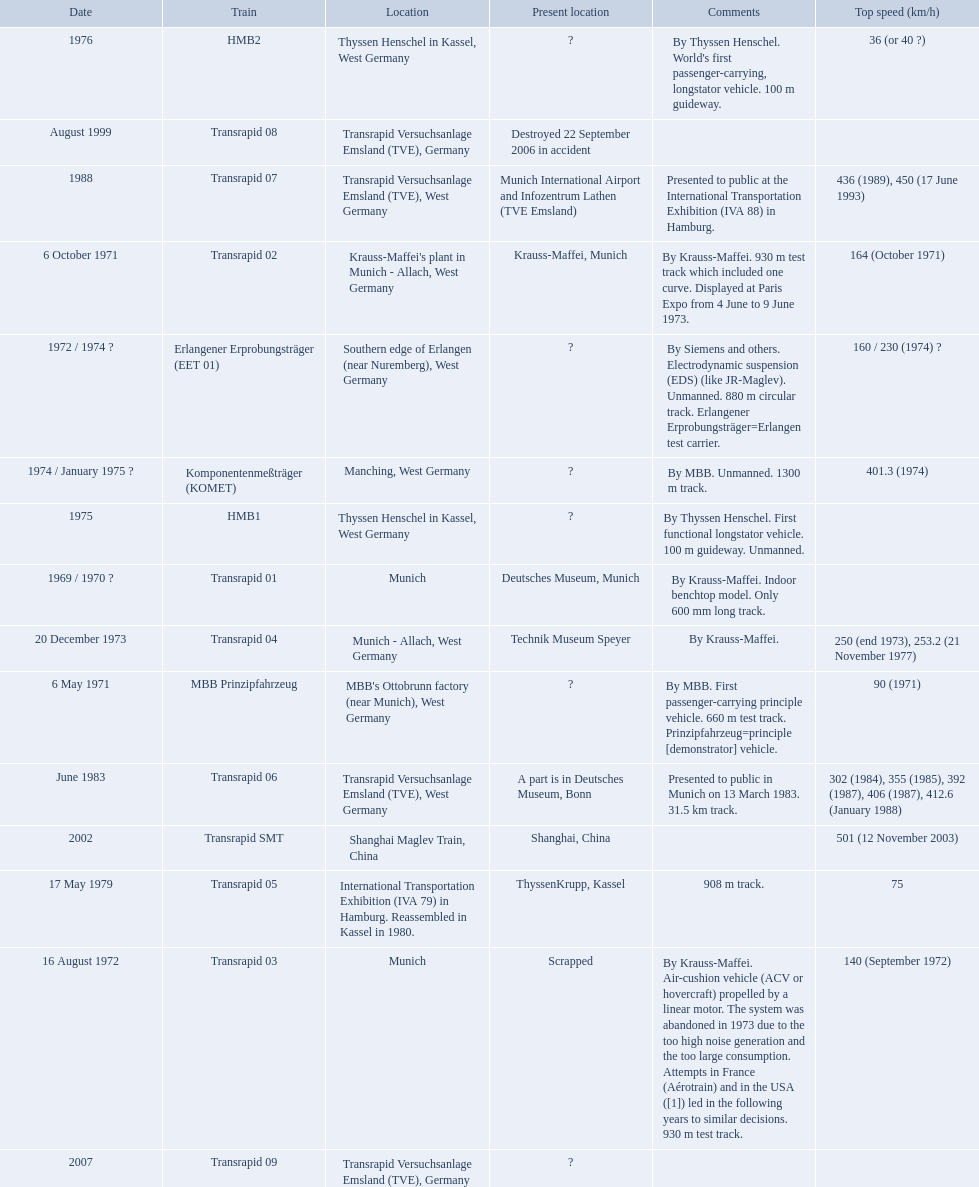What are all trains? Transrapid 01, MBB Prinzipfahrzeug, Transrapid 02, Transrapid 03, Erlangener Erprobungsträger (EET 01), Transrapid 04, Komponentenmeßträger (KOMET), HMB1, HMB2, Transrapid 05, Transrapid 06, Transrapid 07, Transrapid 08, Transrapid SMT, Transrapid 09. Which of all location of trains are known? Deutsches Museum, Munich, Krauss-Maffei, Munich, Scrapped, Technik Museum Speyer, ThyssenKrupp, Kassel, A part is in Deutsches Museum, Bonn, Munich International Airport and Infozentrum Lathen (TVE Emsland), Destroyed 22 September 2006 in accident, Shanghai, China. Which of those trains were scrapped? Transrapid 03. Which trains had a top speed listed? MBB Prinzipfahrzeug, Transrapid 02, Transrapid 03, Erlangener Erprobungsträger (EET 01), Transrapid 04, Komponentenmeßträger (KOMET), HMB2, Transrapid 05, Transrapid 06, Transrapid 07, Transrapid SMT. Which ones list munich as a location? MBB Prinzipfahrzeug, Transrapid 02, Transrapid 03. Of these which ones present location is known? Transrapid 02, Transrapid 03. Which of those is no longer in operation? Transrapid 03. 